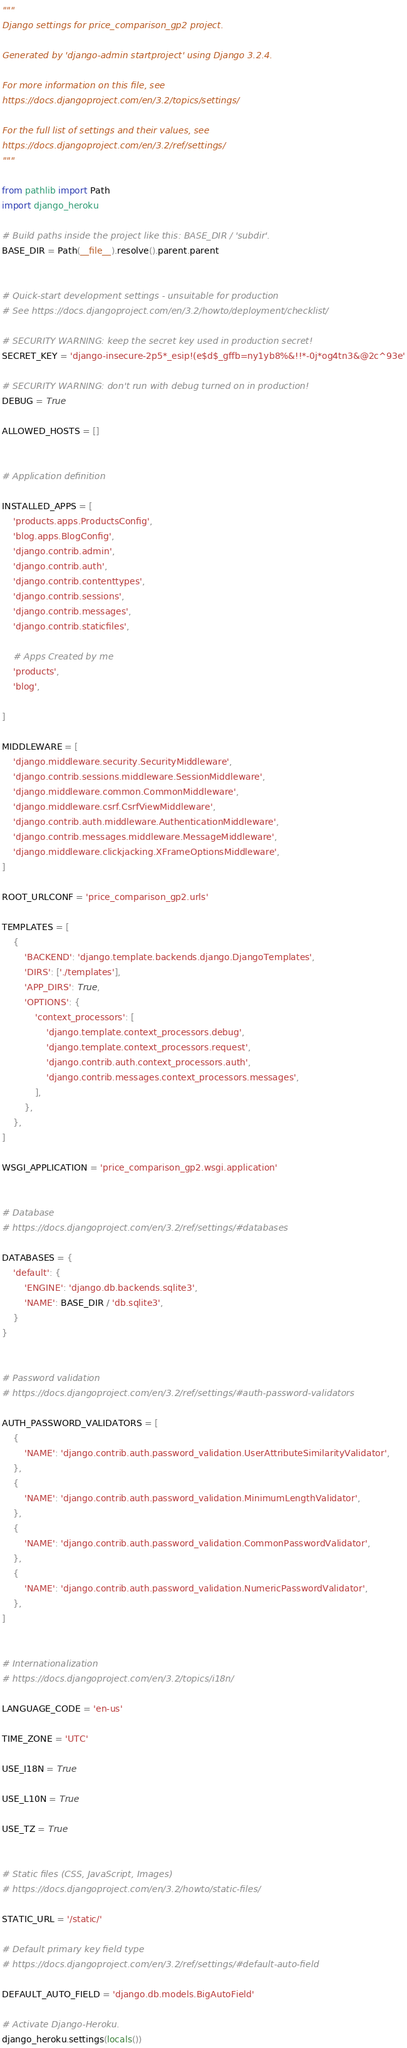Convert code to text. <code><loc_0><loc_0><loc_500><loc_500><_Python_>"""
Django settings for price_comparison_gp2 project.

Generated by 'django-admin startproject' using Django 3.2.4.

For more information on this file, see
https://docs.djangoproject.com/en/3.2/topics/settings/

For the full list of settings and their values, see
https://docs.djangoproject.com/en/3.2/ref/settings/
"""

from pathlib import Path
import django_heroku

# Build paths inside the project like this: BASE_DIR / 'subdir'.
BASE_DIR = Path(__file__).resolve().parent.parent


# Quick-start development settings - unsuitable for production
# See https://docs.djangoproject.com/en/3.2/howto/deployment/checklist/

# SECURITY WARNING: keep the secret key used in production secret!
SECRET_KEY = 'django-insecure-2p5*_esip!(e$d$_gffb=ny1yb8%&!!*-0j*og4tn3&@2c^93e'

# SECURITY WARNING: don't run with debug turned on in production!
DEBUG = True

ALLOWED_HOSTS = []


# Application definition

INSTALLED_APPS = [
    'products.apps.ProductsConfig',
    'blog.apps.BlogConfig',
    'django.contrib.admin',
    'django.contrib.auth',
    'django.contrib.contenttypes',
    'django.contrib.sessions',
    'django.contrib.messages',
    'django.contrib.staticfiles',

    # Apps Created by me
    'products',
    'blog',
    
]

MIDDLEWARE = [
    'django.middleware.security.SecurityMiddleware',
    'django.contrib.sessions.middleware.SessionMiddleware',
    'django.middleware.common.CommonMiddleware',
    'django.middleware.csrf.CsrfViewMiddleware',
    'django.contrib.auth.middleware.AuthenticationMiddleware',
    'django.contrib.messages.middleware.MessageMiddleware',
    'django.middleware.clickjacking.XFrameOptionsMiddleware',
]

ROOT_URLCONF = 'price_comparison_gp2.urls'

TEMPLATES = [
    {
        'BACKEND': 'django.template.backends.django.DjangoTemplates',
        'DIRS': ['./templates'],
        'APP_DIRS': True,
        'OPTIONS': {
            'context_processors': [
                'django.template.context_processors.debug',
                'django.template.context_processors.request',
                'django.contrib.auth.context_processors.auth',
                'django.contrib.messages.context_processors.messages',
            ],
        },
    },
]

WSGI_APPLICATION = 'price_comparison_gp2.wsgi.application'


# Database
# https://docs.djangoproject.com/en/3.2/ref/settings/#databases

DATABASES = {
    'default': {
        'ENGINE': 'django.db.backends.sqlite3',
        'NAME': BASE_DIR / 'db.sqlite3',
    }
}


# Password validation
# https://docs.djangoproject.com/en/3.2/ref/settings/#auth-password-validators

AUTH_PASSWORD_VALIDATORS = [
    {
        'NAME': 'django.contrib.auth.password_validation.UserAttributeSimilarityValidator',
    },
    {
        'NAME': 'django.contrib.auth.password_validation.MinimumLengthValidator',
    },
    {
        'NAME': 'django.contrib.auth.password_validation.CommonPasswordValidator',
    },
    {
        'NAME': 'django.contrib.auth.password_validation.NumericPasswordValidator',
    },
]


# Internationalization
# https://docs.djangoproject.com/en/3.2/topics/i18n/

LANGUAGE_CODE = 'en-us'

TIME_ZONE = 'UTC'

USE_I18N = True

USE_L10N = True

USE_TZ = True


# Static files (CSS, JavaScript, Images)
# https://docs.djangoproject.com/en/3.2/howto/static-files/

STATIC_URL = '/static/'

# Default primary key field type
# https://docs.djangoproject.com/en/3.2/ref/settings/#default-auto-field

DEFAULT_AUTO_FIELD = 'django.db.models.BigAutoField'

# Activate Django-Heroku.
django_heroku.settings(locals())</code> 